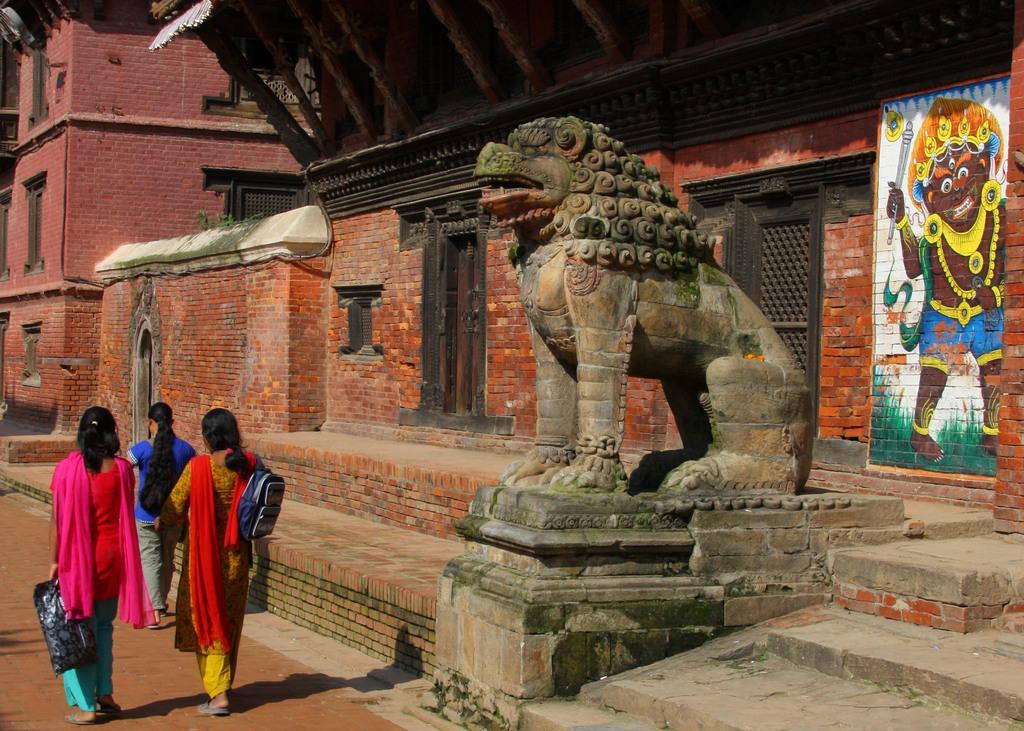In one or two sentences, can you explain what this image depicts? In this picture we can see persons on the ground and in the background we can see a statue,buildings,wall. 